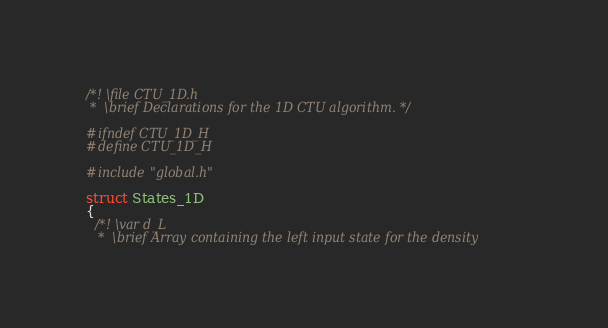<code> <loc_0><loc_0><loc_500><loc_500><_C_>/*! \file CTU_1D.h
 *  \brief Declarations for the 1D CTU algorithm. */

#ifndef CTU_1D_H
#define CTU_1D_H

#include"global.h"

struct States_1D
{
  /*! \var d_L
   *  \brief Array containing the left input state for the density</code> 